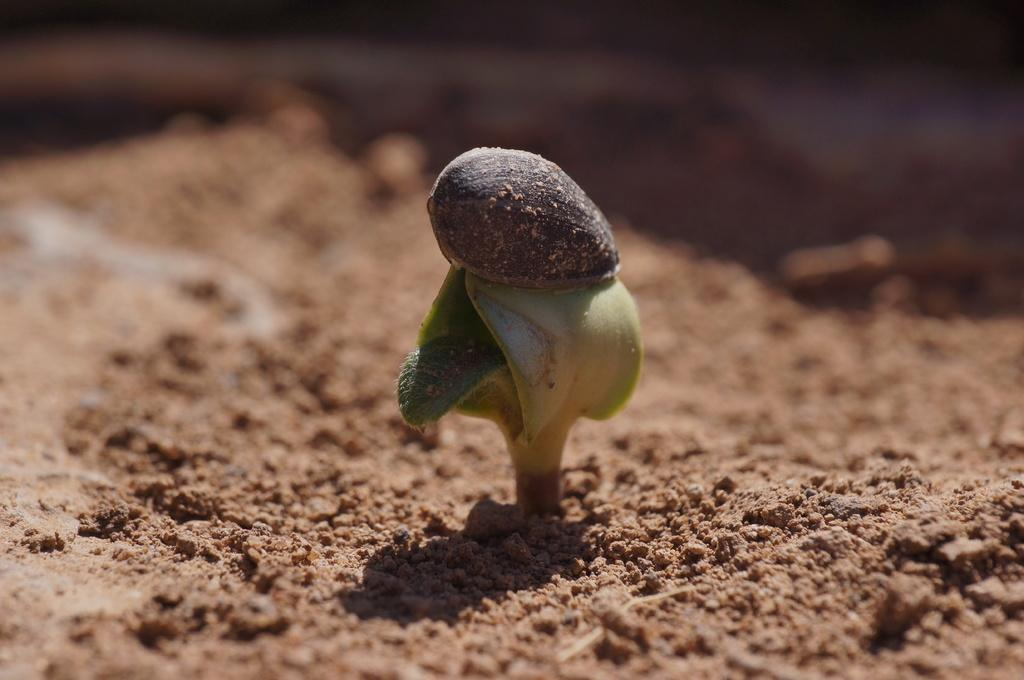What is the main subject in the center of the image? There is a sampling plant in the center of the image. Where is the grandmother sitting in the image? There is no grandmother present in the image; it only features a sampling plant. What type of creature can be seen interacting with the sampling plant in the image? There is no creature present in the image; it only features a sampling plant. 